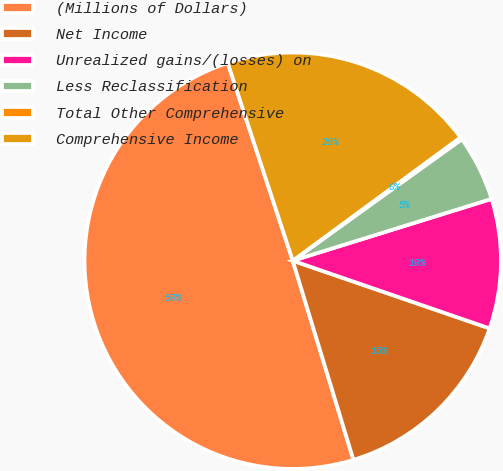Convert chart. <chart><loc_0><loc_0><loc_500><loc_500><pie_chart><fcel>(Millions of Dollars)<fcel>Net Income<fcel>Unrealized gains/(losses) on<fcel>Less Reclassification<fcel>Total Other Comprehensive<fcel>Comprehensive Income<nl><fcel>49.65%<fcel>15.02%<fcel>10.07%<fcel>5.12%<fcel>0.17%<fcel>19.97%<nl></chart> 